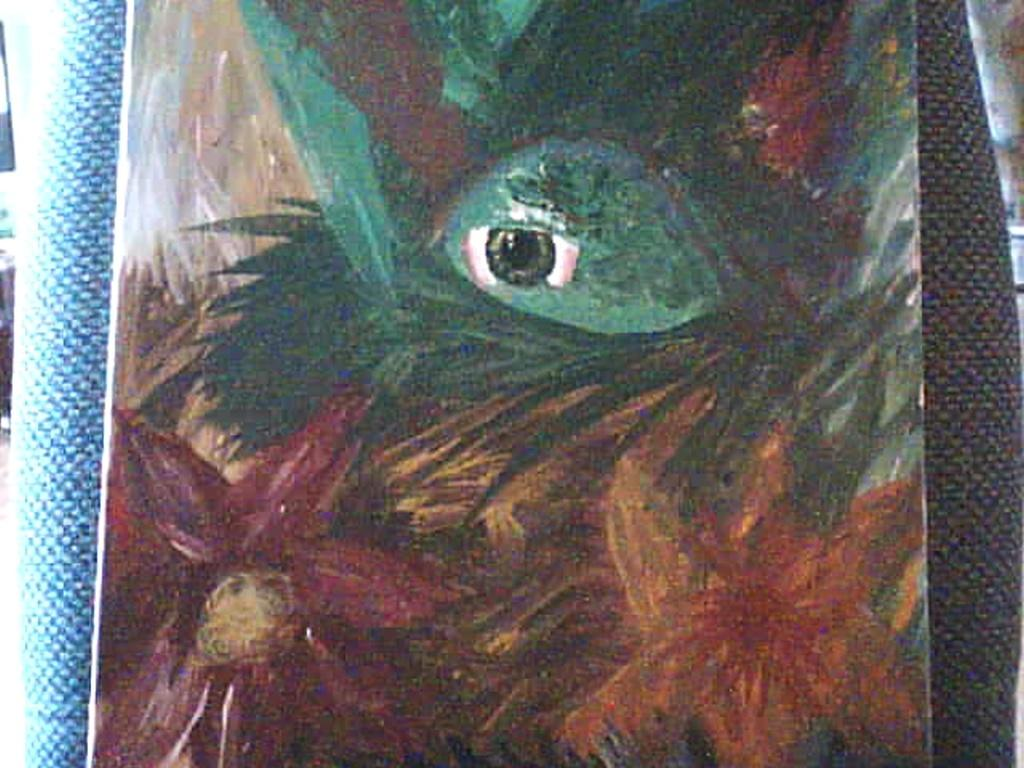What is the main subject of the image? There is a painting in the image. What type of beef is being used to destroy the painting in the image? There is no beef or destruction present in the image; it features a painting. 